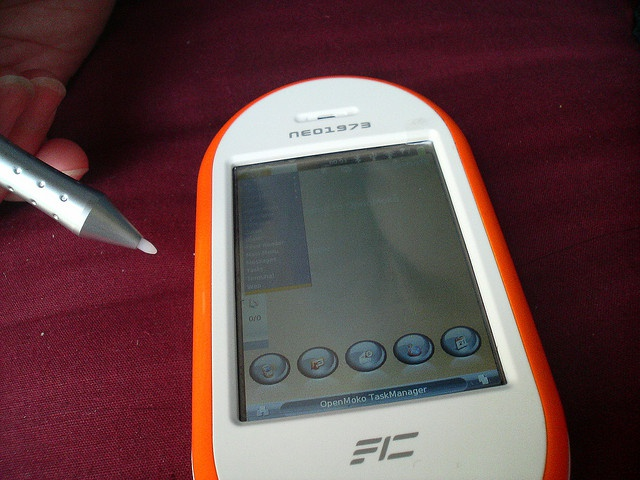Describe the objects in this image and their specific colors. I can see cell phone in black, gray, lightgray, darkgray, and red tones and people in black, maroon, and brown tones in this image. 